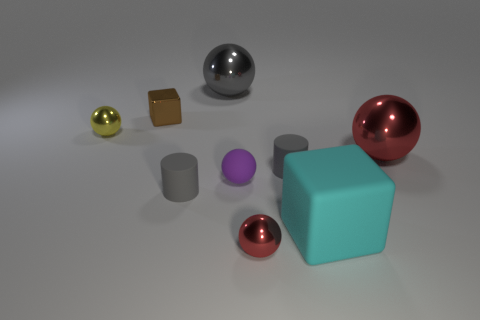What size is the gray thing that is the same shape as the small purple matte thing?
Provide a short and direct response. Large. Is there anything else that is the same size as the matte ball?
Your answer should be very brief. Yes. The brown cube that is behind the tiny yellow object that is to the left of the cyan matte thing is made of what material?
Your answer should be very brief. Metal. Is the brown metallic object the same shape as the big red metallic thing?
Offer a very short reply. No. What number of shiny balls are in front of the big red thing and behind the small yellow metal sphere?
Your answer should be compact. 0. Are there an equal number of small red shiny balls in front of the tiny red metallic thing and brown shiny things behind the big cyan cube?
Your answer should be very brief. No. Do the shiny ball on the left side of the small brown metallic thing and the gray rubber object that is in front of the tiny purple ball have the same size?
Make the answer very short. Yes. There is a ball that is both on the left side of the tiny purple rubber ball and in front of the gray ball; what is its material?
Your answer should be very brief. Metal. Are there fewer purple spheres than large red shiny cylinders?
Make the answer very short. No. How big is the red ball behind the red shiny object on the left side of the cyan object?
Make the answer very short. Large. 